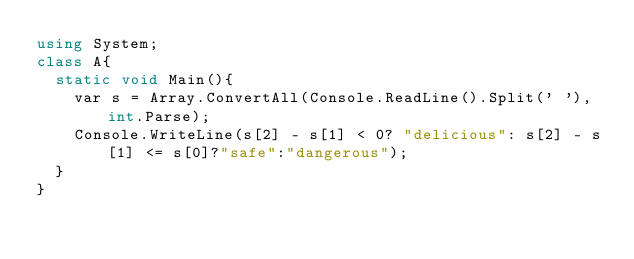<code> <loc_0><loc_0><loc_500><loc_500><_C#_>using System;
class A{
  static void Main(){
    var s = Array.ConvertAll(Console.ReadLine().Split(' '), int.Parse);
    Console.WriteLine(s[2] - s[1] < 0? "delicious": s[2] - s[1] <= s[0]?"safe":"dangerous");
  }
}</code> 